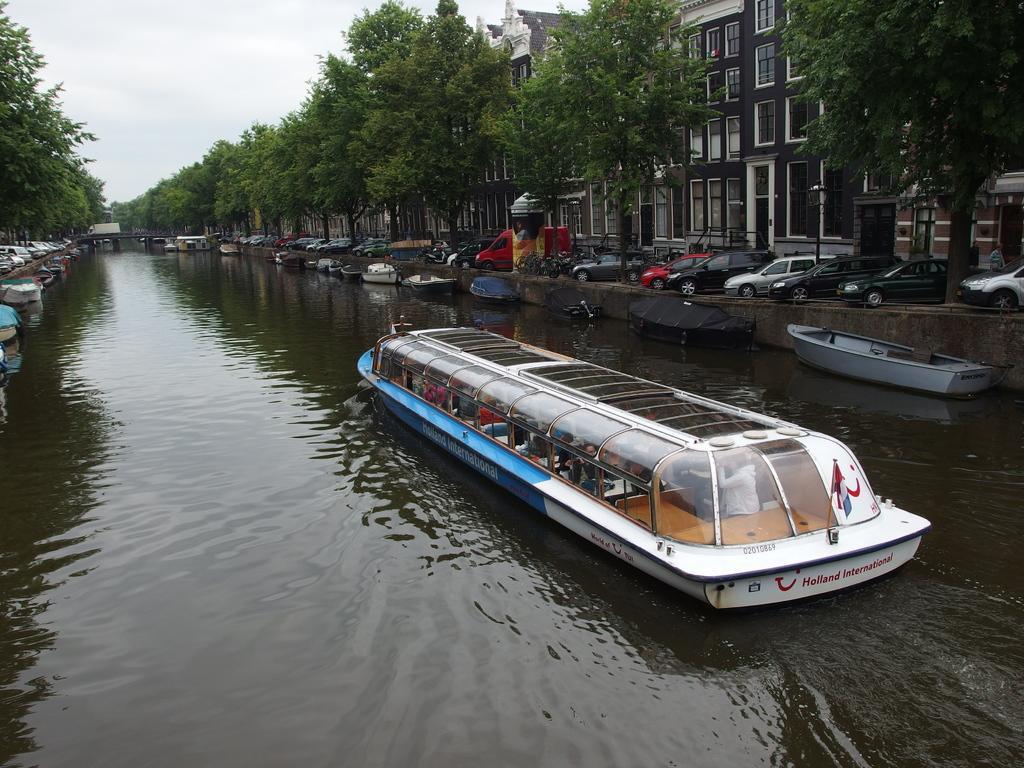Can you describe this image briefly? In this image in the middle there is a boat, inside that there are some people. On the right there are many boats, cars, vehicles, trees, buildings. On the left there are boats, cars, trees, sky and clouds. At the bottom there is water. 